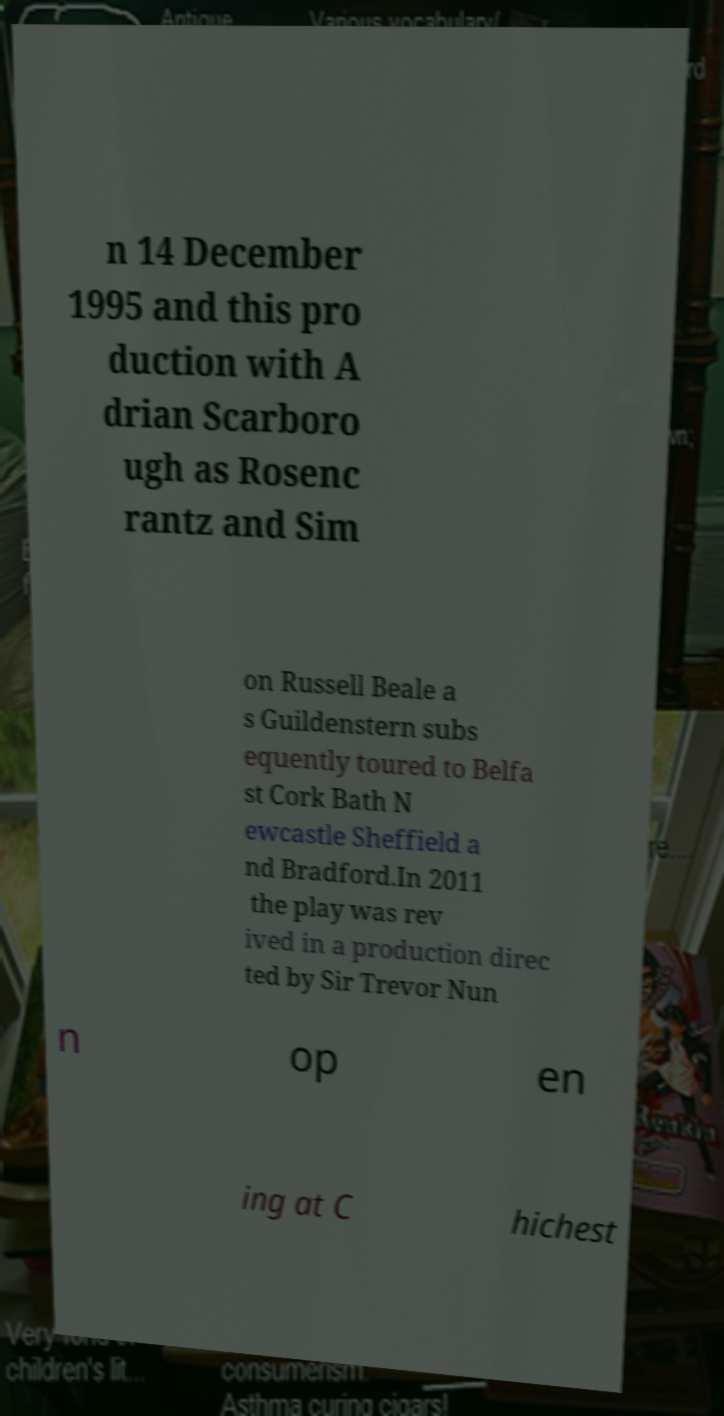For documentation purposes, I need the text within this image transcribed. Could you provide that? n 14 December 1995 and this pro duction with A drian Scarboro ugh as Rosenc rantz and Sim on Russell Beale a s Guildenstern subs equently toured to Belfa st Cork Bath N ewcastle Sheffield a nd Bradford.In 2011 the play was rev ived in a production direc ted by Sir Trevor Nun n op en ing at C hichest 